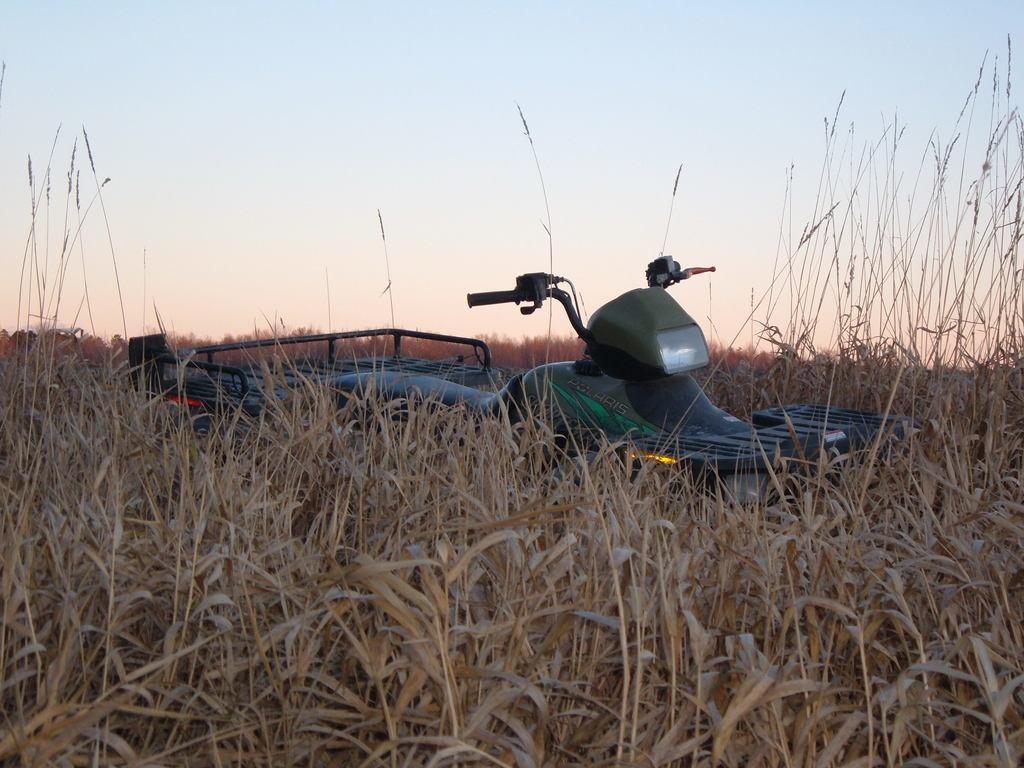In one or two sentences, can you explain what this image depicts? At the bottom of the image I can see the plants. In the background there is a vehicle. At the top of the image I can see the sky. 